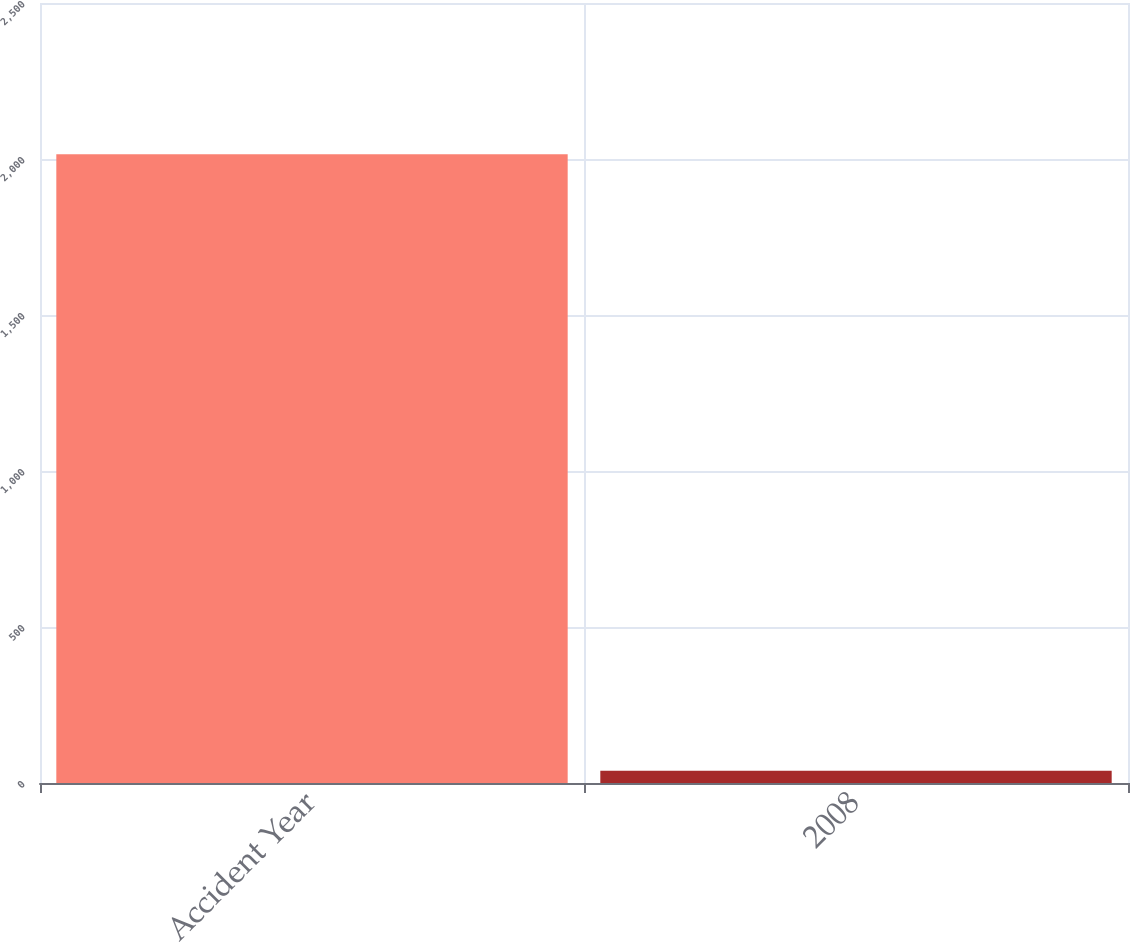Convert chart to OTSL. <chart><loc_0><loc_0><loc_500><loc_500><bar_chart><fcel>Accident Year<fcel>2008<nl><fcel>2015<fcel>39<nl></chart> 